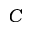Convert formula to latex. <formula><loc_0><loc_0><loc_500><loc_500>C</formula> 